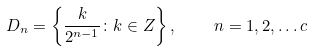<formula> <loc_0><loc_0><loc_500><loc_500>D _ { n } = \left \{ \frac { k } { 2 ^ { n - 1 } } \colon k \in Z \right \} , \quad n = 1 , 2 , \dots c</formula> 